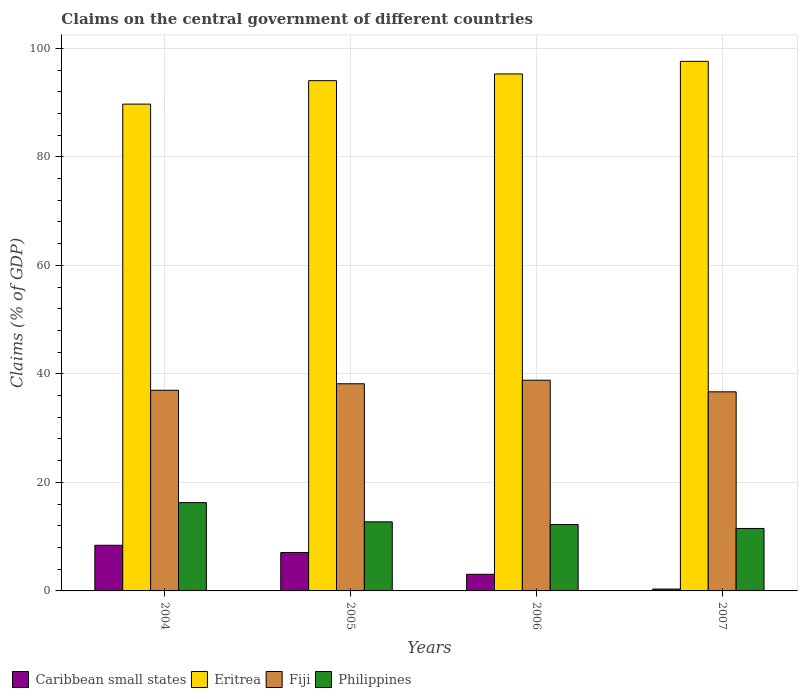How many groups of bars are there?
Make the answer very short. 4. Are the number of bars per tick equal to the number of legend labels?
Offer a terse response. Yes. What is the label of the 1st group of bars from the left?
Offer a very short reply. 2004. What is the percentage of GDP claimed on the central government in Fiji in 2007?
Your response must be concise. 36.69. Across all years, what is the maximum percentage of GDP claimed on the central government in Caribbean small states?
Your response must be concise. 8.41. Across all years, what is the minimum percentage of GDP claimed on the central government in Philippines?
Provide a succinct answer. 11.51. In which year was the percentage of GDP claimed on the central government in Philippines maximum?
Offer a terse response. 2004. What is the total percentage of GDP claimed on the central government in Philippines in the graph?
Offer a very short reply. 52.75. What is the difference between the percentage of GDP claimed on the central government in Caribbean small states in 2006 and that in 2007?
Your answer should be very brief. 2.73. What is the difference between the percentage of GDP claimed on the central government in Philippines in 2005 and the percentage of GDP claimed on the central government in Fiji in 2004?
Ensure brevity in your answer.  -24.25. What is the average percentage of GDP claimed on the central government in Caribbean small states per year?
Your response must be concise. 4.72. In the year 2004, what is the difference between the percentage of GDP claimed on the central government in Fiji and percentage of GDP claimed on the central government in Caribbean small states?
Your response must be concise. 28.57. In how many years, is the percentage of GDP claimed on the central government in Fiji greater than 44 %?
Offer a terse response. 0. What is the ratio of the percentage of GDP claimed on the central government in Eritrea in 2006 to that in 2007?
Provide a short and direct response. 0.98. Is the percentage of GDP claimed on the central government in Fiji in 2004 less than that in 2006?
Your answer should be compact. Yes. Is the difference between the percentage of GDP claimed on the central government in Fiji in 2004 and 2005 greater than the difference between the percentage of GDP claimed on the central government in Caribbean small states in 2004 and 2005?
Provide a short and direct response. No. What is the difference between the highest and the second highest percentage of GDP claimed on the central government in Fiji?
Provide a succinct answer. 0.65. What is the difference between the highest and the lowest percentage of GDP claimed on the central government in Caribbean small states?
Give a very brief answer. 8.07. In how many years, is the percentage of GDP claimed on the central government in Philippines greater than the average percentage of GDP claimed on the central government in Philippines taken over all years?
Your response must be concise. 1. Is the sum of the percentage of GDP claimed on the central government in Caribbean small states in 2004 and 2005 greater than the maximum percentage of GDP claimed on the central government in Fiji across all years?
Give a very brief answer. No. Is it the case that in every year, the sum of the percentage of GDP claimed on the central government in Fiji and percentage of GDP claimed on the central government in Philippines is greater than the sum of percentage of GDP claimed on the central government in Eritrea and percentage of GDP claimed on the central government in Caribbean small states?
Provide a succinct answer. Yes. What does the 2nd bar from the left in 2004 represents?
Make the answer very short. Eritrea. What does the 3rd bar from the right in 2005 represents?
Your answer should be compact. Eritrea. How many bars are there?
Offer a terse response. 16. Are all the bars in the graph horizontal?
Give a very brief answer. No. Does the graph contain grids?
Keep it short and to the point. Yes. Where does the legend appear in the graph?
Keep it short and to the point. Bottom left. How many legend labels are there?
Your response must be concise. 4. How are the legend labels stacked?
Your answer should be very brief. Horizontal. What is the title of the graph?
Your answer should be compact. Claims on the central government of different countries. Does "Nepal" appear as one of the legend labels in the graph?
Your answer should be very brief. No. What is the label or title of the X-axis?
Make the answer very short. Years. What is the label or title of the Y-axis?
Make the answer very short. Claims (% of GDP). What is the Claims (% of GDP) of Caribbean small states in 2004?
Ensure brevity in your answer.  8.41. What is the Claims (% of GDP) of Eritrea in 2004?
Offer a very short reply. 89.72. What is the Claims (% of GDP) in Fiji in 2004?
Your answer should be very brief. 36.98. What is the Claims (% of GDP) in Philippines in 2004?
Ensure brevity in your answer.  16.27. What is the Claims (% of GDP) of Caribbean small states in 2005?
Provide a succinct answer. 7.07. What is the Claims (% of GDP) of Eritrea in 2005?
Provide a succinct answer. 94.04. What is the Claims (% of GDP) in Fiji in 2005?
Your response must be concise. 38.18. What is the Claims (% of GDP) in Philippines in 2005?
Your answer should be compact. 12.73. What is the Claims (% of GDP) in Caribbean small states in 2006?
Your response must be concise. 3.07. What is the Claims (% of GDP) in Eritrea in 2006?
Give a very brief answer. 95.28. What is the Claims (% of GDP) in Fiji in 2006?
Provide a short and direct response. 38.83. What is the Claims (% of GDP) of Philippines in 2006?
Your answer should be compact. 12.23. What is the Claims (% of GDP) in Caribbean small states in 2007?
Provide a short and direct response. 0.34. What is the Claims (% of GDP) of Eritrea in 2007?
Make the answer very short. 97.6. What is the Claims (% of GDP) of Fiji in 2007?
Provide a succinct answer. 36.69. What is the Claims (% of GDP) in Philippines in 2007?
Make the answer very short. 11.51. Across all years, what is the maximum Claims (% of GDP) in Caribbean small states?
Make the answer very short. 8.41. Across all years, what is the maximum Claims (% of GDP) in Eritrea?
Keep it short and to the point. 97.6. Across all years, what is the maximum Claims (% of GDP) of Fiji?
Provide a short and direct response. 38.83. Across all years, what is the maximum Claims (% of GDP) in Philippines?
Offer a very short reply. 16.27. Across all years, what is the minimum Claims (% of GDP) in Caribbean small states?
Your answer should be compact. 0.34. Across all years, what is the minimum Claims (% of GDP) in Eritrea?
Offer a very short reply. 89.72. Across all years, what is the minimum Claims (% of GDP) of Fiji?
Provide a short and direct response. 36.69. Across all years, what is the minimum Claims (% of GDP) in Philippines?
Offer a very short reply. 11.51. What is the total Claims (% of GDP) of Caribbean small states in the graph?
Give a very brief answer. 18.9. What is the total Claims (% of GDP) of Eritrea in the graph?
Offer a terse response. 376.64. What is the total Claims (% of GDP) in Fiji in the graph?
Make the answer very short. 150.69. What is the total Claims (% of GDP) in Philippines in the graph?
Offer a terse response. 52.75. What is the difference between the Claims (% of GDP) of Caribbean small states in 2004 and that in 2005?
Offer a terse response. 1.34. What is the difference between the Claims (% of GDP) in Eritrea in 2004 and that in 2005?
Provide a succinct answer. -4.32. What is the difference between the Claims (% of GDP) in Fiji in 2004 and that in 2005?
Your answer should be very brief. -1.2. What is the difference between the Claims (% of GDP) in Philippines in 2004 and that in 2005?
Provide a short and direct response. 3.53. What is the difference between the Claims (% of GDP) of Caribbean small states in 2004 and that in 2006?
Provide a succinct answer. 5.35. What is the difference between the Claims (% of GDP) in Eritrea in 2004 and that in 2006?
Your response must be concise. -5.56. What is the difference between the Claims (% of GDP) in Fiji in 2004 and that in 2006?
Offer a very short reply. -1.85. What is the difference between the Claims (% of GDP) of Philippines in 2004 and that in 2006?
Provide a short and direct response. 4.04. What is the difference between the Claims (% of GDP) in Caribbean small states in 2004 and that in 2007?
Provide a short and direct response. 8.07. What is the difference between the Claims (% of GDP) in Eritrea in 2004 and that in 2007?
Your answer should be compact. -7.88. What is the difference between the Claims (% of GDP) of Fiji in 2004 and that in 2007?
Provide a succinct answer. 0.29. What is the difference between the Claims (% of GDP) in Philippines in 2004 and that in 2007?
Your answer should be very brief. 4.76. What is the difference between the Claims (% of GDP) in Caribbean small states in 2005 and that in 2006?
Your answer should be compact. 4.01. What is the difference between the Claims (% of GDP) in Eritrea in 2005 and that in 2006?
Ensure brevity in your answer.  -1.24. What is the difference between the Claims (% of GDP) in Fiji in 2005 and that in 2006?
Your response must be concise. -0.65. What is the difference between the Claims (% of GDP) of Philippines in 2005 and that in 2006?
Make the answer very short. 0.5. What is the difference between the Claims (% of GDP) in Caribbean small states in 2005 and that in 2007?
Provide a short and direct response. 6.73. What is the difference between the Claims (% of GDP) in Eritrea in 2005 and that in 2007?
Provide a short and direct response. -3.56. What is the difference between the Claims (% of GDP) in Fiji in 2005 and that in 2007?
Offer a very short reply. 1.49. What is the difference between the Claims (% of GDP) of Philippines in 2005 and that in 2007?
Your response must be concise. 1.22. What is the difference between the Claims (% of GDP) of Caribbean small states in 2006 and that in 2007?
Keep it short and to the point. 2.73. What is the difference between the Claims (% of GDP) of Eritrea in 2006 and that in 2007?
Make the answer very short. -2.32. What is the difference between the Claims (% of GDP) of Fiji in 2006 and that in 2007?
Your response must be concise. 2.14. What is the difference between the Claims (% of GDP) in Philippines in 2006 and that in 2007?
Your answer should be compact. 0.72. What is the difference between the Claims (% of GDP) in Caribbean small states in 2004 and the Claims (% of GDP) in Eritrea in 2005?
Provide a short and direct response. -85.62. What is the difference between the Claims (% of GDP) in Caribbean small states in 2004 and the Claims (% of GDP) in Fiji in 2005?
Provide a succinct answer. -29.77. What is the difference between the Claims (% of GDP) in Caribbean small states in 2004 and the Claims (% of GDP) in Philippines in 2005?
Offer a terse response. -4.32. What is the difference between the Claims (% of GDP) of Eritrea in 2004 and the Claims (% of GDP) of Fiji in 2005?
Give a very brief answer. 51.54. What is the difference between the Claims (% of GDP) of Eritrea in 2004 and the Claims (% of GDP) of Philippines in 2005?
Provide a short and direct response. 76.98. What is the difference between the Claims (% of GDP) in Fiji in 2004 and the Claims (% of GDP) in Philippines in 2005?
Your answer should be compact. 24.25. What is the difference between the Claims (% of GDP) in Caribbean small states in 2004 and the Claims (% of GDP) in Eritrea in 2006?
Make the answer very short. -86.87. What is the difference between the Claims (% of GDP) of Caribbean small states in 2004 and the Claims (% of GDP) of Fiji in 2006?
Your answer should be very brief. -30.42. What is the difference between the Claims (% of GDP) in Caribbean small states in 2004 and the Claims (% of GDP) in Philippines in 2006?
Give a very brief answer. -3.82. What is the difference between the Claims (% of GDP) of Eritrea in 2004 and the Claims (% of GDP) of Fiji in 2006?
Make the answer very short. 50.88. What is the difference between the Claims (% of GDP) in Eritrea in 2004 and the Claims (% of GDP) in Philippines in 2006?
Offer a terse response. 77.49. What is the difference between the Claims (% of GDP) in Fiji in 2004 and the Claims (% of GDP) in Philippines in 2006?
Your response must be concise. 24.75. What is the difference between the Claims (% of GDP) of Caribbean small states in 2004 and the Claims (% of GDP) of Eritrea in 2007?
Your answer should be compact. -89.19. What is the difference between the Claims (% of GDP) of Caribbean small states in 2004 and the Claims (% of GDP) of Fiji in 2007?
Provide a succinct answer. -28.28. What is the difference between the Claims (% of GDP) in Caribbean small states in 2004 and the Claims (% of GDP) in Philippines in 2007?
Your answer should be very brief. -3.1. What is the difference between the Claims (% of GDP) of Eritrea in 2004 and the Claims (% of GDP) of Fiji in 2007?
Offer a very short reply. 53.02. What is the difference between the Claims (% of GDP) of Eritrea in 2004 and the Claims (% of GDP) of Philippines in 2007?
Your response must be concise. 78.21. What is the difference between the Claims (% of GDP) in Fiji in 2004 and the Claims (% of GDP) in Philippines in 2007?
Keep it short and to the point. 25.47. What is the difference between the Claims (% of GDP) in Caribbean small states in 2005 and the Claims (% of GDP) in Eritrea in 2006?
Provide a short and direct response. -88.21. What is the difference between the Claims (% of GDP) in Caribbean small states in 2005 and the Claims (% of GDP) in Fiji in 2006?
Provide a succinct answer. -31.76. What is the difference between the Claims (% of GDP) in Caribbean small states in 2005 and the Claims (% of GDP) in Philippines in 2006?
Make the answer very short. -5.16. What is the difference between the Claims (% of GDP) of Eritrea in 2005 and the Claims (% of GDP) of Fiji in 2006?
Ensure brevity in your answer.  55.2. What is the difference between the Claims (% of GDP) in Eritrea in 2005 and the Claims (% of GDP) in Philippines in 2006?
Ensure brevity in your answer.  81.81. What is the difference between the Claims (% of GDP) of Fiji in 2005 and the Claims (% of GDP) of Philippines in 2006?
Keep it short and to the point. 25.95. What is the difference between the Claims (% of GDP) in Caribbean small states in 2005 and the Claims (% of GDP) in Eritrea in 2007?
Your answer should be compact. -90.53. What is the difference between the Claims (% of GDP) of Caribbean small states in 2005 and the Claims (% of GDP) of Fiji in 2007?
Your answer should be compact. -29.62. What is the difference between the Claims (% of GDP) in Caribbean small states in 2005 and the Claims (% of GDP) in Philippines in 2007?
Your answer should be very brief. -4.44. What is the difference between the Claims (% of GDP) in Eritrea in 2005 and the Claims (% of GDP) in Fiji in 2007?
Give a very brief answer. 57.35. What is the difference between the Claims (% of GDP) in Eritrea in 2005 and the Claims (% of GDP) in Philippines in 2007?
Your answer should be very brief. 82.53. What is the difference between the Claims (% of GDP) of Fiji in 2005 and the Claims (% of GDP) of Philippines in 2007?
Keep it short and to the point. 26.67. What is the difference between the Claims (% of GDP) of Caribbean small states in 2006 and the Claims (% of GDP) of Eritrea in 2007?
Keep it short and to the point. -94.53. What is the difference between the Claims (% of GDP) of Caribbean small states in 2006 and the Claims (% of GDP) of Fiji in 2007?
Provide a short and direct response. -33.63. What is the difference between the Claims (% of GDP) of Caribbean small states in 2006 and the Claims (% of GDP) of Philippines in 2007?
Provide a succinct answer. -8.44. What is the difference between the Claims (% of GDP) in Eritrea in 2006 and the Claims (% of GDP) in Fiji in 2007?
Offer a very short reply. 58.59. What is the difference between the Claims (% of GDP) in Eritrea in 2006 and the Claims (% of GDP) in Philippines in 2007?
Offer a very short reply. 83.77. What is the difference between the Claims (% of GDP) in Fiji in 2006 and the Claims (% of GDP) in Philippines in 2007?
Keep it short and to the point. 27.32. What is the average Claims (% of GDP) of Caribbean small states per year?
Your response must be concise. 4.72. What is the average Claims (% of GDP) of Eritrea per year?
Your response must be concise. 94.16. What is the average Claims (% of GDP) of Fiji per year?
Keep it short and to the point. 37.67. What is the average Claims (% of GDP) of Philippines per year?
Offer a very short reply. 13.19. In the year 2004, what is the difference between the Claims (% of GDP) of Caribbean small states and Claims (% of GDP) of Eritrea?
Provide a succinct answer. -81.3. In the year 2004, what is the difference between the Claims (% of GDP) of Caribbean small states and Claims (% of GDP) of Fiji?
Offer a terse response. -28.57. In the year 2004, what is the difference between the Claims (% of GDP) in Caribbean small states and Claims (% of GDP) in Philippines?
Offer a terse response. -7.85. In the year 2004, what is the difference between the Claims (% of GDP) in Eritrea and Claims (% of GDP) in Fiji?
Offer a terse response. 52.73. In the year 2004, what is the difference between the Claims (% of GDP) of Eritrea and Claims (% of GDP) of Philippines?
Keep it short and to the point. 73.45. In the year 2004, what is the difference between the Claims (% of GDP) of Fiji and Claims (% of GDP) of Philippines?
Offer a very short reply. 20.72. In the year 2005, what is the difference between the Claims (% of GDP) in Caribbean small states and Claims (% of GDP) in Eritrea?
Provide a short and direct response. -86.96. In the year 2005, what is the difference between the Claims (% of GDP) in Caribbean small states and Claims (% of GDP) in Fiji?
Your response must be concise. -31.11. In the year 2005, what is the difference between the Claims (% of GDP) of Caribbean small states and Claims (% of GDP) of Philippines?
Your answer should be compact. -5.66. In the year 2005, what is the difference between the Claims (% of GDP) of Eritrea and Claims (% of GDP) of Fiji?
Provide a succinct answer. 55.86. In the year 2005, what is the difference between the Claims (% of GDP) of Eritrea and Claims (% of GDP) of Philippines?
Make the answer very short. 81.31. In the year 2005, what is the difference between the Claims (% of GDP) of Fiji and Claims (% of GDP) of Philippines?
Give a very brief answer. 25.45. In the year 2006, what is the difference between the Claims (% of GDP) of Caribbean small states and Claims (% of GDP) of Eritrea?
Your answer should be compact. -92.21. In the year 2006, what is the difference between the Claims (% of GDP) of Caribbean small states and Claims (% of GDP) of Fiji?
Provide a succinct answer. -35.77. In the year 2006, what is the difference between the Claims (% of GDP) in Caribbean small states and Claims (% of GDP) in Philippines?
Your answer should be very brief. -9.16. In the year 2006, what is the difference between the Claims (% of GDP) in Eritrea and Claims (% of GDP) in Fiji?
Provide a succinct answer. 56.45. In the year 2006, what is the difference between the Claims (% of GDP) in Eritrea and Claims (% of GDP) in Philippines?
Offer a terse response. 83.05. In the year 2006, what is the difference between the Claims (% of GDP) in Fiji and Claims (% of GDP) in Philippines?
Offer a very short reply. 26.6. In the year 2007, what is the difference between the Claims (% of GDP) in Caribbean small states and Claims (% of GDP) in Eritrea?
Your response must be concise. -97.26. In the year 2007, what is the difference between the Claims (% of GDP) in Caribbean small states and Claims (% of GDP) in Fiji?
Make the answer very short. -36.35. In the year 2007, what is the difference between the Claims (% of GDP) of Caribbean small states and Claims (% of GDP) of Philippines?
Give a very brief answer. -11.17. In the year 2007, what is the difference between the Claims (% of GDP) of Eritrea and Claims (% of GDP) of Fiji?
Keep it short and to the point. 60.91. In the year 2007, what is the difference between the Claims (% of GDP) in Eritrea and Claims (% of GDP) in Philippines?
Your answer should be compact. 86.09. In the year 2007, what is the difference between the Claims (% of GDP) of Fiji and Claims (% of GDP) of Philippines?
Your answer should be very brief. 25.18. What is the ratio of the Claims (% of GDP) of Caribbean small states in 2004 to that in 2005?
Keep it short and to the point. 1.19. What is the ratio of the Claims (% of GDP) in Eritrea in 2004 to that in 2005?
Your answer should be compact. 0.95. What is the ratio of the Claims (% of GDP) of Fiji in 2004 to that in 2005?
Provide a succinct answer. 0.97. What is the ratio of the Claims (% of GDP) in Philippines in 2004 to that in 2005?
Keep it short and to the point. 1.28. What is the ratio of the Claims (% of GDP) in Caribbean small states in 2004 to that in 2006?
Give a very brief answer. 2.74. What is the ratio of the Claims (% of GDP) of Eritrea in 2004 to that in 2006?
Your answer should be very brief. 0.94. What is the ratio of the Claims (% of GDP) of Fiji in 2004 to that in 2006?
Provide a short and direct response. 0.95. What is the ratio of the Claims (% of GDP) in Philippines in 2004 to that in 2006?
Offer a terse response. 1.33. What is the ratio of the Claims (% of GDP) in Caribbean small states in 2004 to that in 2007?
Ensure brevity in your answer.  24.59. What is the ratio of the Claims (% of GDP) of Eritrea in 2004 to that in 2007?
Offer a very short reply. 0.92. What is the ratio of the Claims (% of GDP) in Fiji in 2004 to that in 2007?
Provide a short and direct response. 1.01. What is the ratio of the Claims (% of GDP) of Philippines in 2004 to that in 2007?
Your answer should be compact. 1.41. What is the ratio of the Claims (% of GDP) of Caribbean small states in 2005 to that in 2006?
Your answer should be compact. 2.31. What is the ratio of the Claims (% of GDP) in Eritrea in 2005 to that in 2006?
Provide a short and direct response. 0.99. What is the ratio of the Claims (% of GDP) in Fiji in 2005 to that in 2006?
Provide a short and direct response. 0.98. What is the ratio of the Claims (% of GDP) in Philippines in 2005 to that in 2006?
Your answer should be compact. 1.04. What is the ratio of the Claims (% of GDP) in Caribbean small states in 2005 to that in 2007?
Give a very brief answer. 20.67. What is the ratio of the Claims (% of GDP) of Eritrea in 2005 to that in 2007?
Make the answer very short. 0.96. What is the ratio of the Claims (% of GDP) in Fiji in 2005 to that in 2007?
Your answer should be compact. 1.04. What is the ratio of the Claims (% of GDP) in Philippines in 2005 to that in 2007?
Keep it short and to the point. 1.11. What is the ratio of the Claims (% of GDP) in Caribbean small states in 2006 to that in 2007?
Keep it short and to the point. 8.96. What is the ratio of the Claims (% of GDP) of Eritrea in 2006 to that in 2007?
Provide a succinct answer. 0.98. What is the ratio of the Claims (% of GDP) in Fiji in 2006 to that in 2007?
Make the answer very short. 1.06. What is the difference between the highest and the second highest Claims (% of GDP) in Caribbean small states?
Your response must be concise. 1.34. What is the difference between the highest and the second highest Claims (% of GDP) of Eritrea?
Provide a succinct answer. 2.32. What is the difference between the highest and the second highest Claims (% of GDP) in Fiji?
Give a very brief answer. 0.65. What is the difference between the highest and the second highest Claims (% of GDP) in Philippines?
Your answer should be very brief. 3.53. What is the difference between the highest and the lowest Claims (% of GDP) in Caribbean small states?
Your response must be concise. 8.07. What is the difference between the highest and the lowest Claims (% of GDP) of Eritrea?
Give a very brief answer. 7.88. What is the difference between the highest and the lowest Claims (% of GDP) of Fiji?
Make the answer very short. 2.14. What is the difference between the highest and the lowest Claims (% of GDP) in Philippines?
Your answer should be very brief. 4.76. 